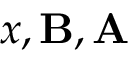<formula> <loc_0><loc_0><loc_500><loc_500>x , B , A</formula> 